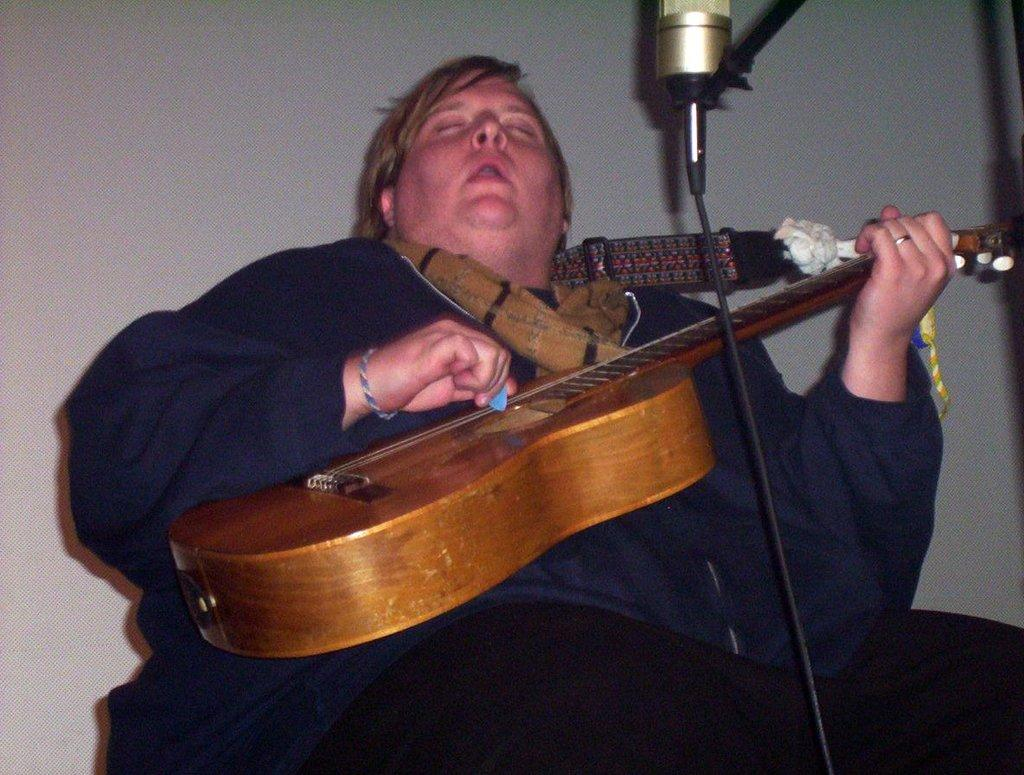What is the person in the image doing? The person is sitting and playing a guitar. What object is in front of the person? There is a microphone in front of the person. What can be seen in the background of the image? There is a wall in the background of the image. What type of silver can be seen on the person's fingers while they play the guitar? There is no silver visible on the person's fingers in the image. Can you tell me how much salt is on the wall in the background? There is no salt present on the wall in the background of the image. 